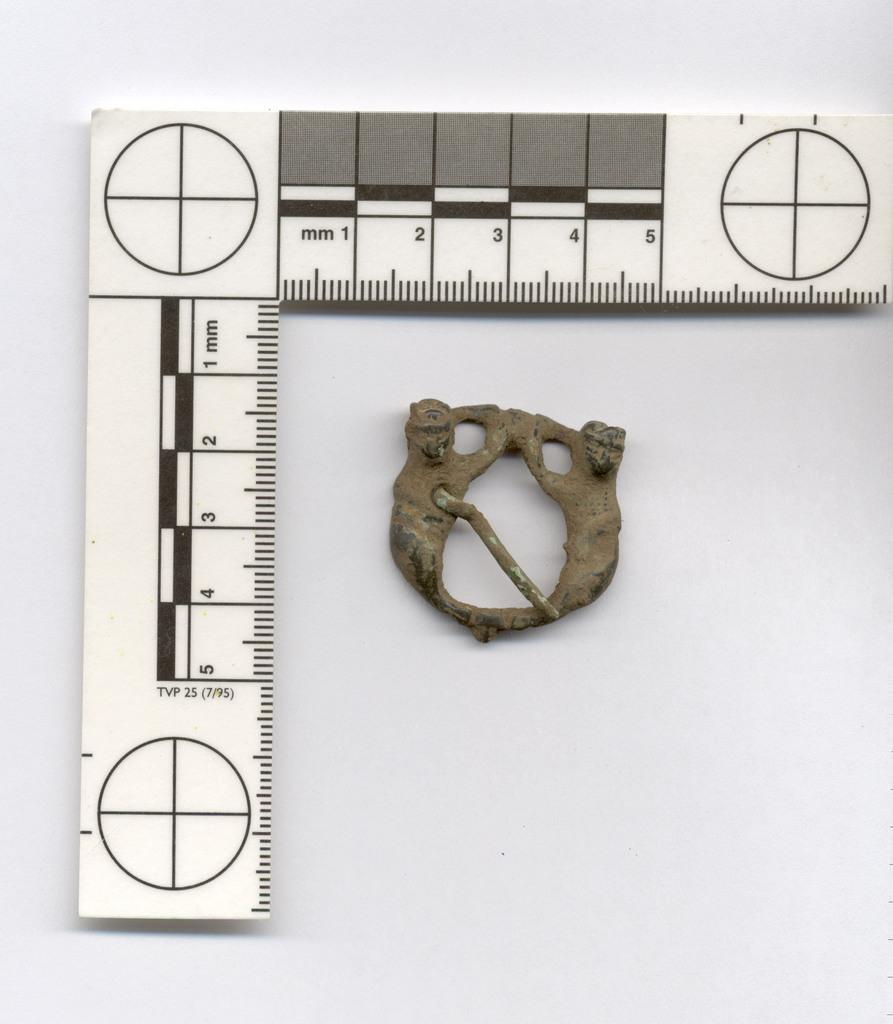What type of tool is present in the image? There is a marking tool with numbers in the image. What can be found in the center of the image? There is an antique piece in the center of the image. Where is the hose connected to the pump in the image? There is no hose or pump present in the image. What type of apple is on the antique piece in the image? There is no apple present in the image; it only features a marking tool and an antique piece. 